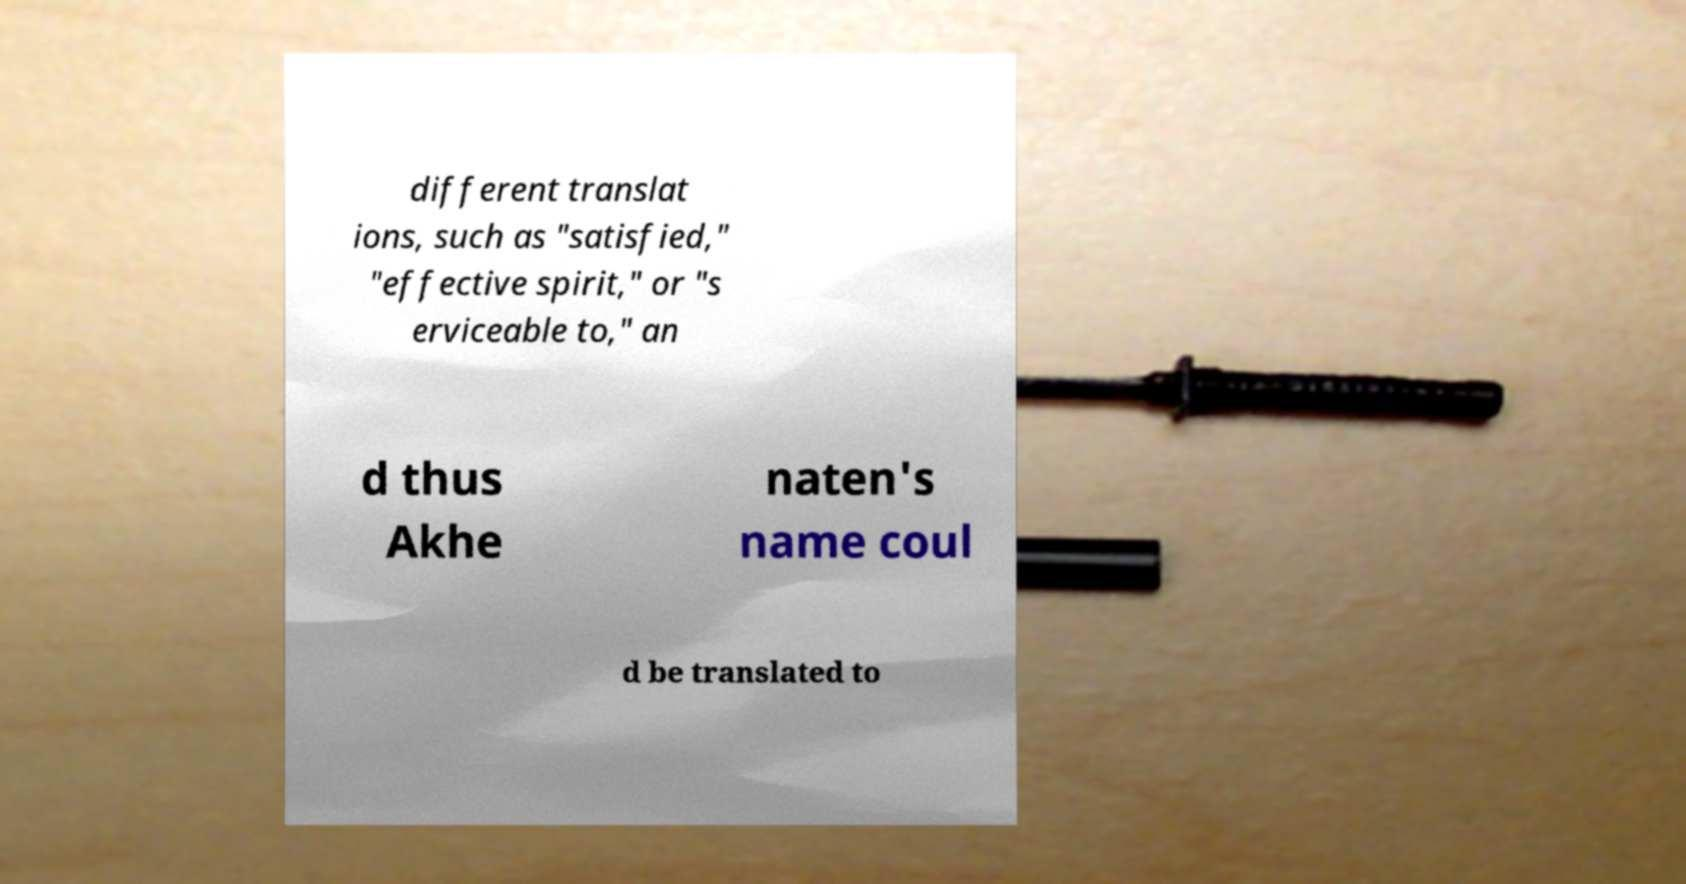Please read and relay the text visible in this image. What does it say? different translat ions, such as "satisfied," "effective spirit," or "s erviceable to," an d thus Akhe naten's name coul d be translated to 